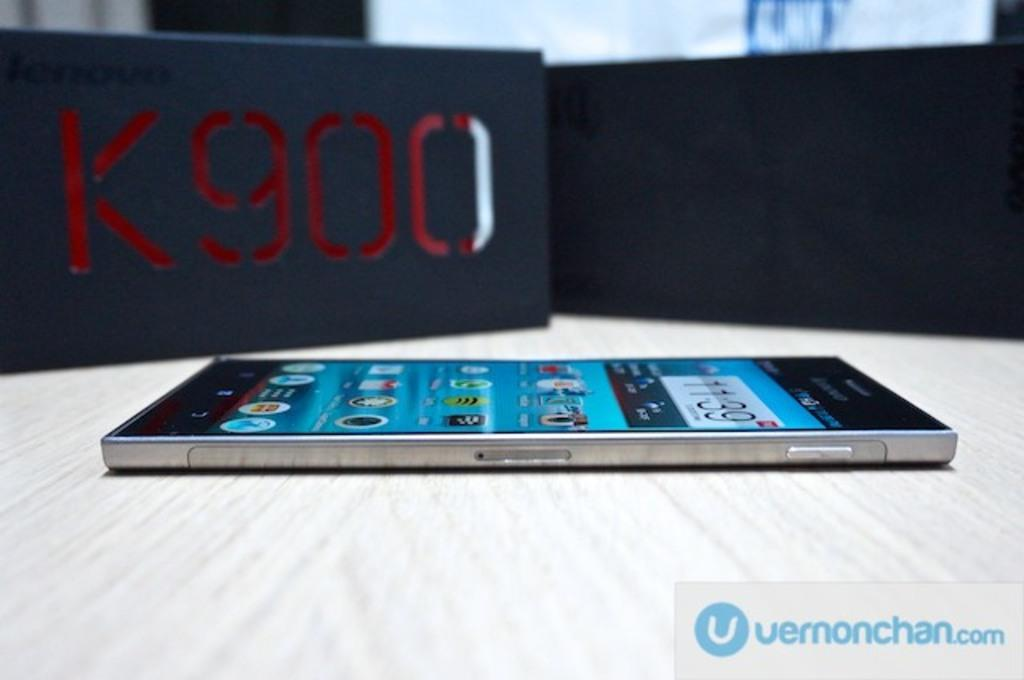<image>
Offer a succinct explanation of the picture presented. A smart phone is on a table next to a black box with K900 on it. 